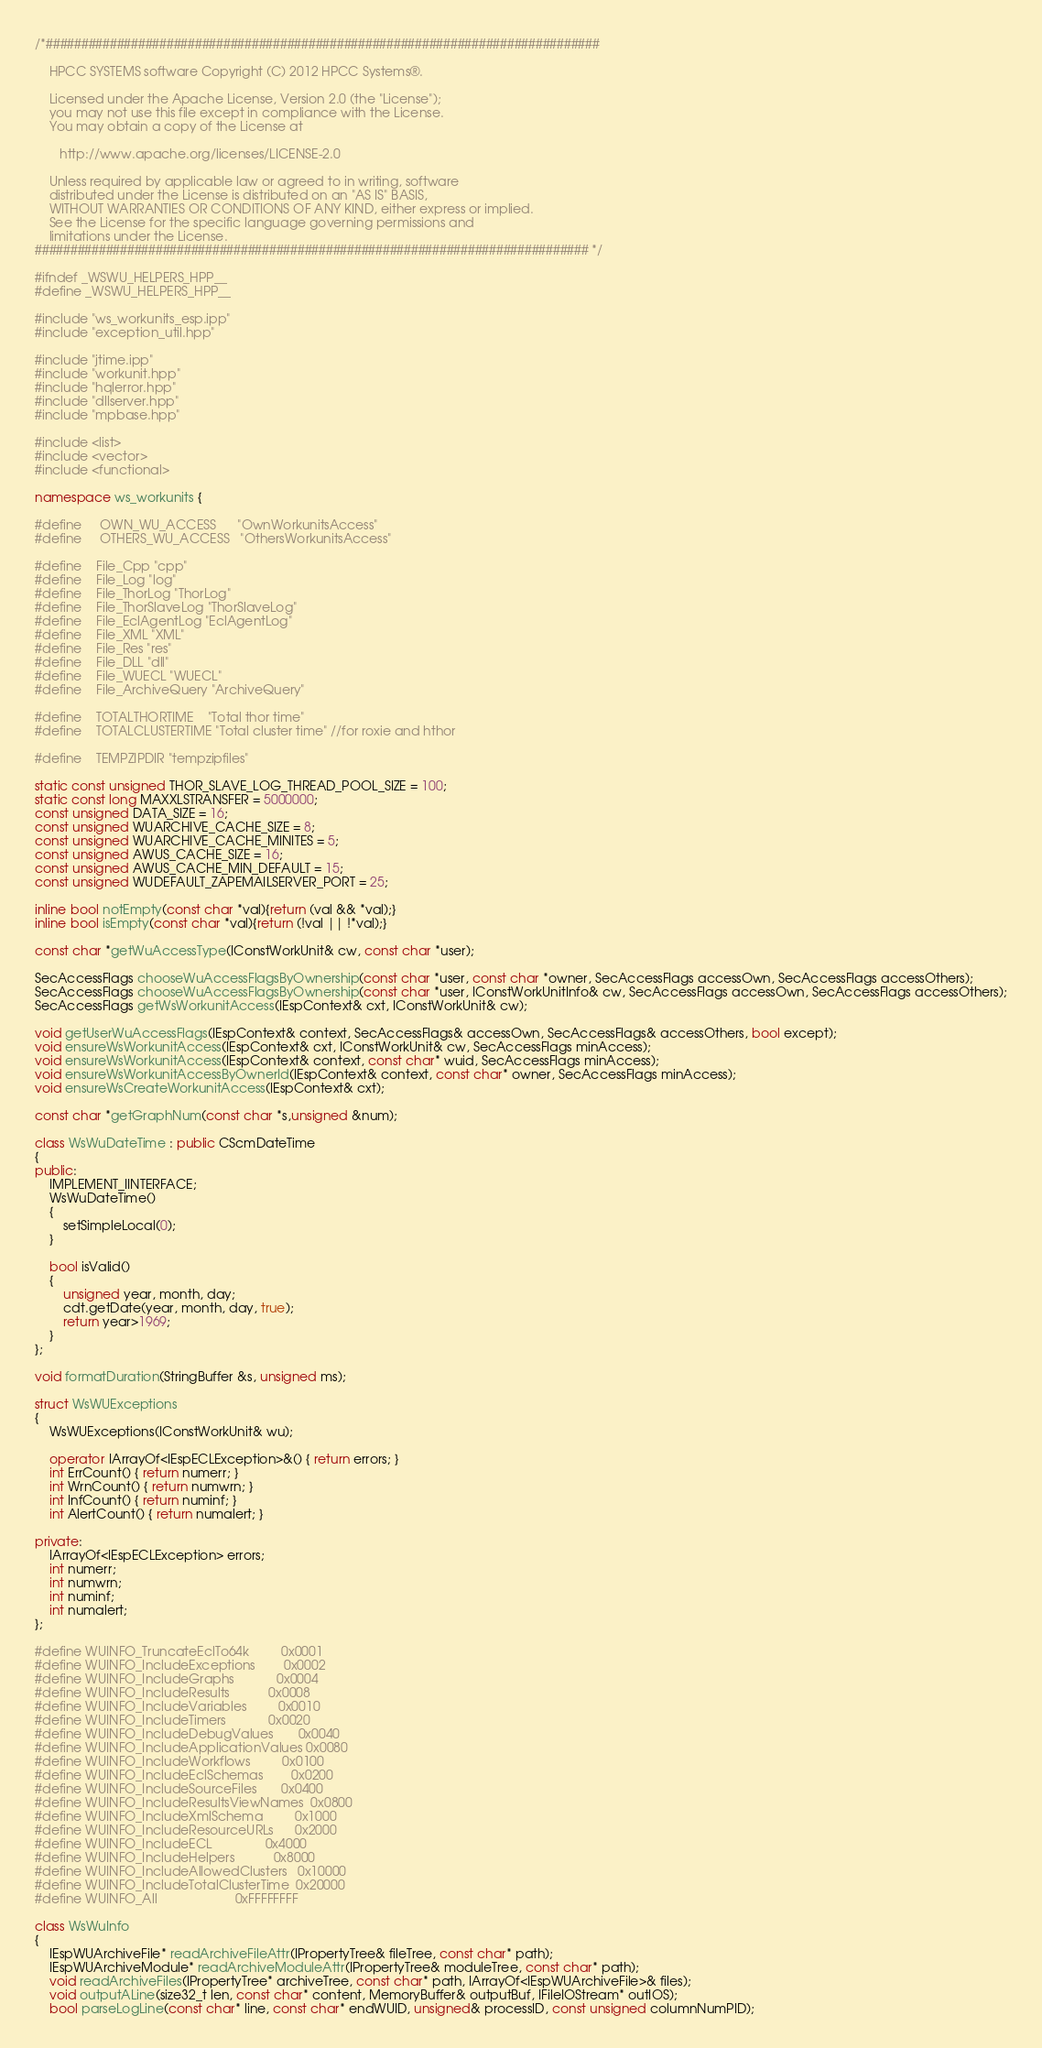Convert code to text. <code><loc_0><loc_0><loc_500><loc_500><_C++_>/*##############################################################################

    HPCC SYSTEMS software Copyright (C) 2012 HPCC Systems®.

    Licensed under the Apache License, Version 2.0 (the "License");
    you may not use this file except in compliance with the License.
    You may obtain a copy of the License at

       http://www.apache.org/licenses/LICENSE-2.0

    Unless required by applicable law or agreed to in writing, software
    distributed under the License is distributed on an "AS IS" BASIS,
    WITHOUT WARRANTIES OR CONDITIONS OF ANY KIND, either express or implied.
    See the License for the specific language governing permissions and
    limitations under the License.
############################################################################## */

#ifndef _WSWU_HELPERS_HPP__
#define _WSWU_HELPERS_HPP__

#include "ws_workunits_esp.ipp"
#include "exception_util.hpp"

#include "jtime.ipp"
#include "workunit.hpp"
#include "hqlerror.hpp"
#include "dllserver.hpp"
#include "mpbase.hpp"

#include <list>
#include <vector>
#include <functional>

namespace ws_workunits {

#define     OWN_WU_ACCESS      "OwnWorkunitsAccess"
#define     OTHERS_WU_ACCESS   "OthersWorkunitsAccess"

#define    File_Cpp "cpp"
#define    File_Log "log"
#define    File_ThorLog "ThorLog"
#define    File_ThorSlaveLog "ThorSlaveLog"
#define    File_EclAgentLog "EclAgentLog"
#define    File_XML "XML"
#define    File_Res "res"
#define    File_DLL "dll"
#define    File_WUECL "WUECL"
#define    File_ArchiveQuery "ArchiveQuery"

#define    TOTALTHORTIME    "Total thor time"
#define    TOTALCLUSTERTIME "Total cluster time" //for roxie and hthor

#define    TEMPZIPDIR "tempzipfiles"

static const unsigned THOR_SLAVE_LOG_THREAD_POOL_SIZE = 100;
static const long MAXXLSTRANSFER = 5000000;
const unsigned DATA_SIZE = 16;
const unsigned WUARCHIVE_CACHE_SIZE = 8;
const unsigned WUARCHIVE_CACHE_MINITES = 5;
const unsigned AWUS_CACHE_SIZE = 16;
const unsigned AWUS_CACHE_MIN_DEFAULT = 15;
const unsigned WUDEFAULT_ZAPEMAILSERVER_PORT = 25;

inline bool notEmpty(const char *val){return (val && *val);}
inline bool isEmpty(const char *val){return (!val || !*val);}

const char *getWuAccessType(IConstWorkUnit& cw, const char *user);

SecAccessFlags chooseWuAccessFlagsByOwnership(const char *user, const char *owner, SecAccessFlags accessOwn, SecAccessFlags accessOthers);
SecAccessFlags chooseWuAccessFlagsByOwnership(const char *user, IConstWorkUnitInfo& cw, SecAccessFlags accessOwn, SecAccessFlags accessOthers);
SecAccessFlags getWsWorkunitAccess(IEspContext& cxt, IConstWorkUnit& cw);

void getUserWuAccessFlags(IEspContext& context, SecAccessFlags& accessOwn, SecAccessFlags& accessOthers, bool except);
void ensureWsWorkunitAccess(IEspContext& cxt, IConstWorkUnit& cw, SecAccessFlags minAccess);
void ensureWsWorkunitAccess(IEspContext& context, const char* wuid, SecAccessFlags minAccess);
void ensureWsWorkunitAccessByOwnerId(IEspContext& context, const char* owner, SecAccessFlags minAccess);
void ensureWsCreateWorkunitAccess(IEspContext& cxt);

const char *getGraphNum(const char *s,unsigned &num);

class WsWuDateTime : public CScmDateTime
{
public:
    IMPLEMENT_IINTERFACE;
    WsWuDateTime()
    {
        setSimpleLocal(0);
    }

    bool isValid()
    {
        unsigned year, month, day;
        cdt.getDate(year, month, day, true);
        return year>1969;
    }
};

void formatDuration(StringBuffer &s, unsigned ms);

struct WsWUExceptions
{
    WsWUExceptions(IConstWorkUnit& wu);

    operator IArrayOf<IEspECLException>&() { return errors; }
    int ErrCount() { return numerr; }
    int WrnCount() { return numwrn; }
    int InfCount() { return numinf; }
    int AlertCount() { return numalert; }

private:
    IArrayOf<IEspECLException> errors;
    int numerr;
    int numwrn;
    int numinf;
    int numalert;
};

#define WUINFO_TruncateEclTo64k         0x0001
#define WUINFO_IncludeExceptions        0x0002
#define WUINFO_IncludeGraphs            0x0004
#define WUINFO_IncludeResults           0x0008
#define WUINFO_IncludeVariables         0x0010
#define WUINFO_IncludeTimers            0x0020
#define WUINFO_IncludeDebugValues       0x0040
#define WUINFO_IncludeApplicationValues 0x0080
#define WUINFO_IncludeWorkflows         0x0100
#define WUINFO_IncludeEclSchemas        0x0200
#define WUINFO_IncludeSourceFiles       0x0400
#define WUINFO_IncludeResultsViewNames  0x0800
#define WUINFO_IncludeXmlSchema         0x1000
#define WUINFO_IncludeResourceURLs      0x2000
#define WUINFO_IncludeECL               0x4000
#define WUINFO_IncludeHelpers           0x8000
#define WUINFO_IncludeAllowedClusters   0x10000
#define WUINFO_IncludeTotalClusterTime  0x20000
#define WUINFO_All                      0xFFFFFFFF

class WsWuInfo
{
    IEspWUArchiveFile* readArchiveFileAttr(IPropertyTree& fileTree, const char* path);
    IEspWUArchiveModule* readArchiveModuleAttr(IPropertyTree& moduleTree, const char* path);
    void readArchiveFiles(IPropertyTree* archiveTree, const char* path, IArrayOf<IEspWUArchiveFile>& files);
    void outputALine(size32_t len, const char* content, MemoryBuffer& outputBuf, IFileIOStream* outIOS);
    bool parseLogLine(const char* line, const char* endWUID, unsigned& processID, const unsigned columnNumPID);</code> 